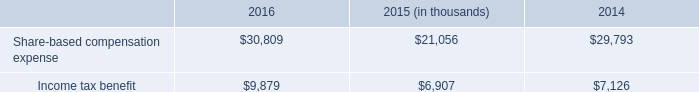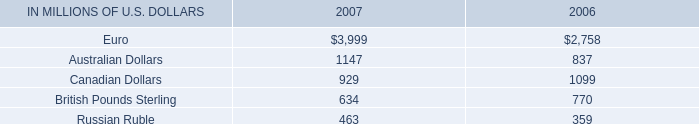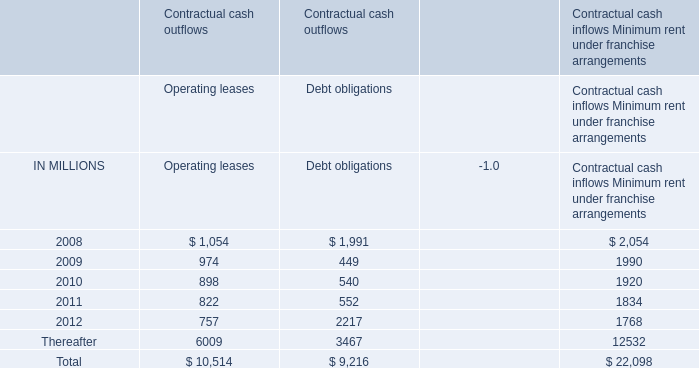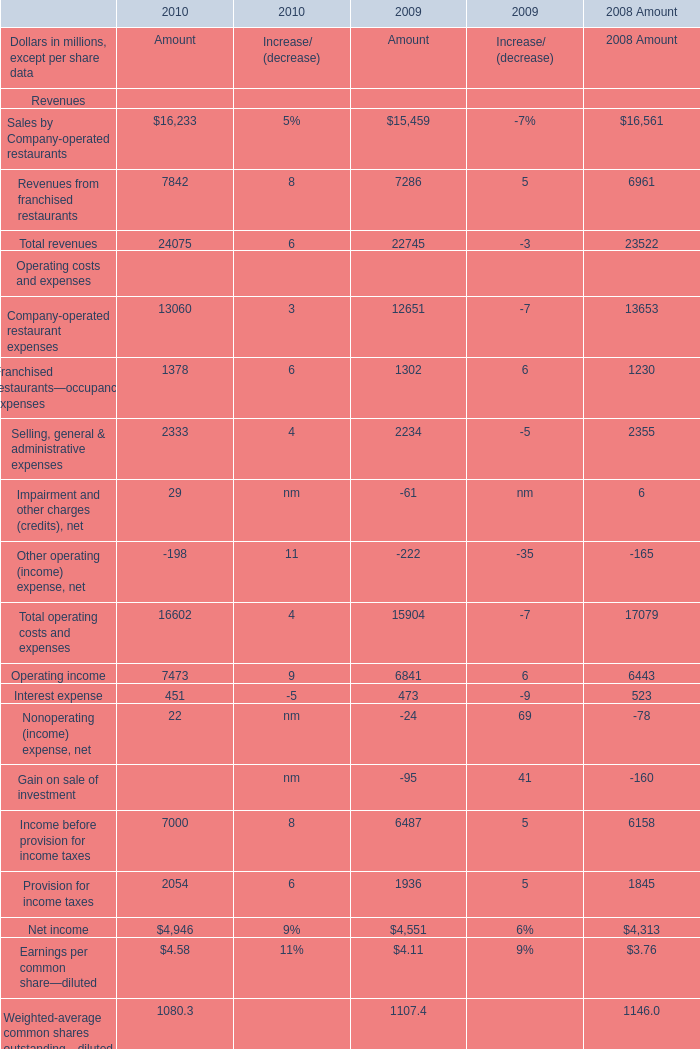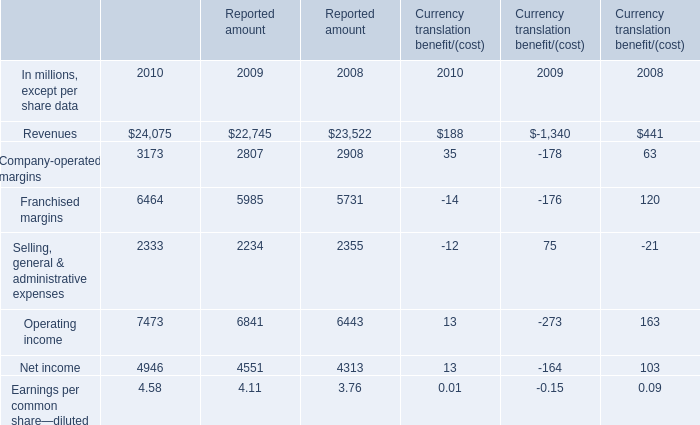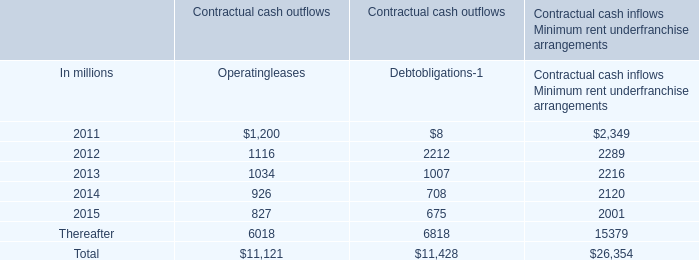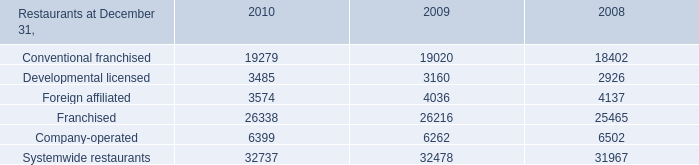Does Company-operated restaurant expenses for Amout keeps increasing each year between 2009 and 2008? 
Answer: No. 